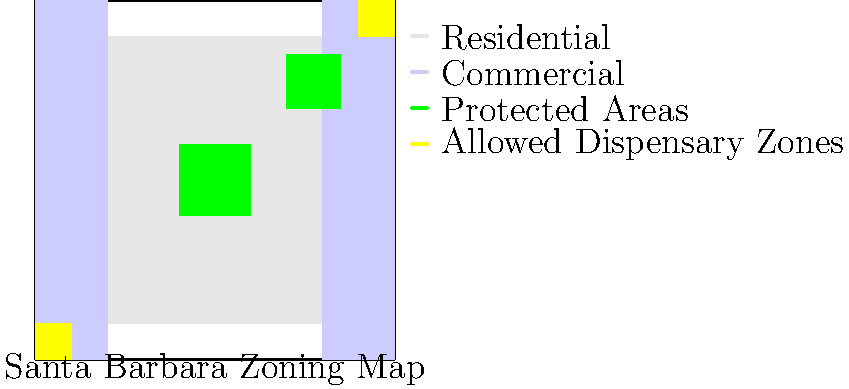Based on the zoning map of Santa Barbara, what percentage of the city's area is designated for marijuana dispensaries? To determine the percentage of Santa Barbara's area designated for marijuana dispensaries, we need to follow these steps:

1. Observe the map layout:
   - The entire city is represented by a 100x100 unit square.
   - The total area of the city is therefore 10,000 square units.

2. Identify the areas designated for marijuana dispensaries:
   - There are two small yellow squares in opposite corners of the map.
   - Each square appears to be 10x10 units.

3. Calculate the total area for dispensaries:
   - Area of one square: $10 \times 10 = 100$ square units
   - Total area for dispensaries: $100 \times 2 = 200$ square units

4. Calculate the percentage:
   - Percentage = (Area for dispensaries / Total city area) × 100
   - $\frac{200}{10,000} \times 100 = 0.02 \times 100 = 2\%$

Therefore, the area designated for marijuana dispensaries is 2% of the total city area.
Answer: 2% 